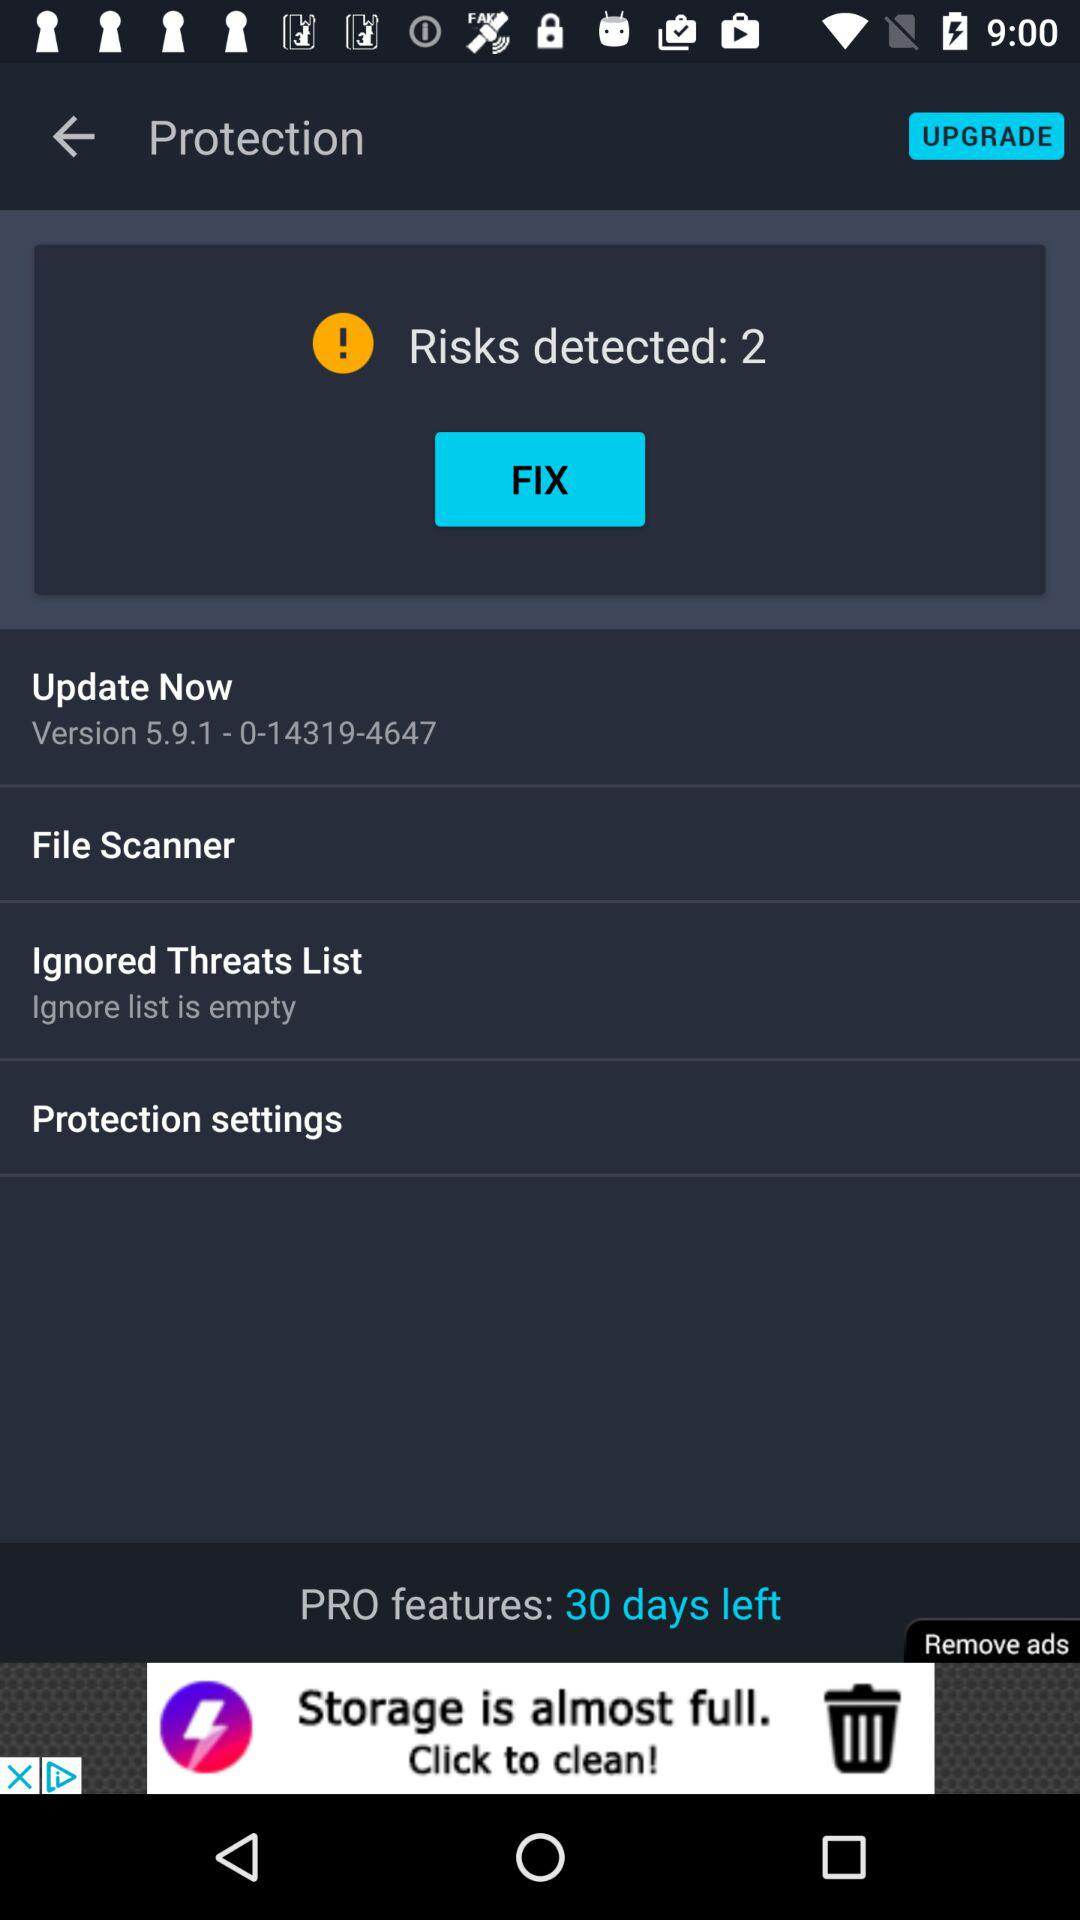How many risks have been detected?
Answer the question using a single word or phrase. 2 